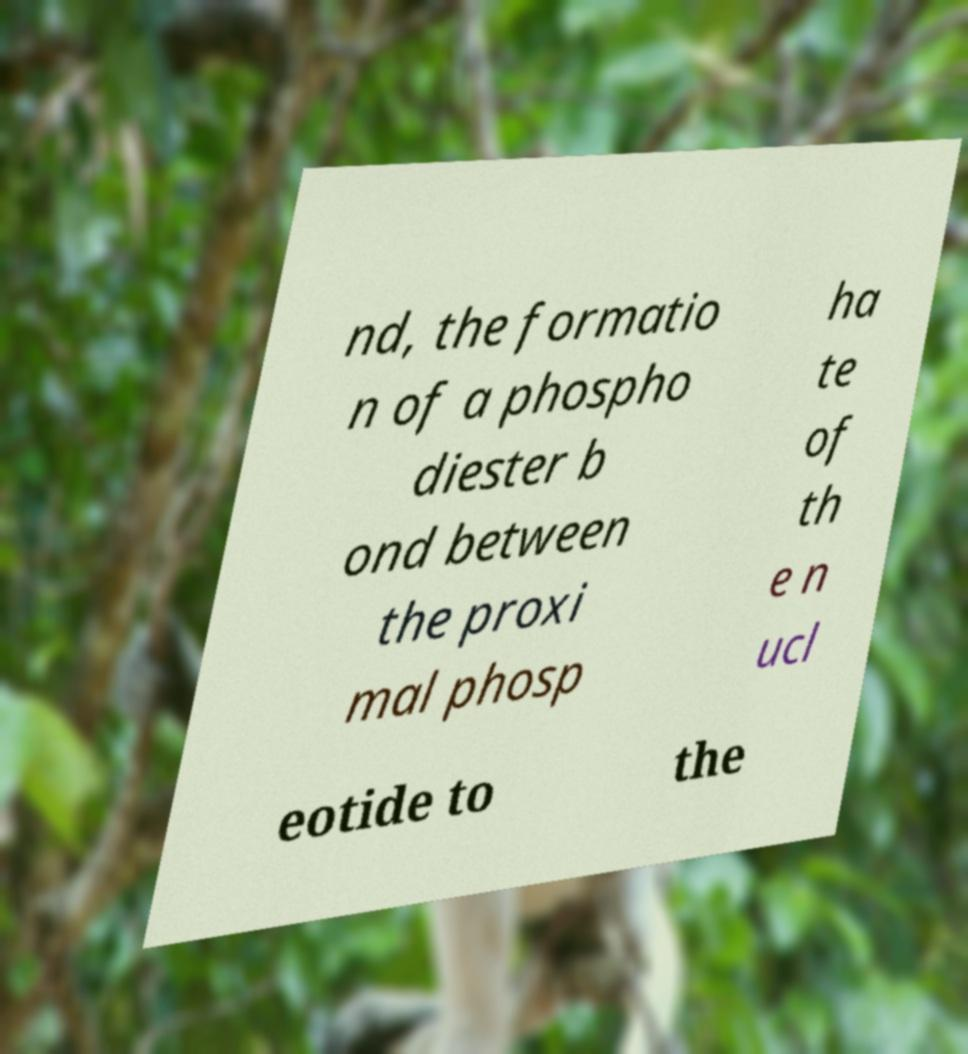What messages or text are displayed in this image? I need them in a readable, typed format. nd, the formatio n of a phospho diester b ond between the proxi mal phosp ha te of th e n ucl eotide to the 